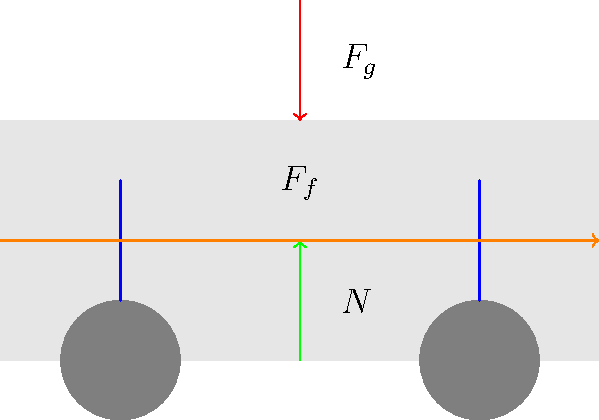During emergency braking, a truck's weight shifts forward, affecting the suspension system. If the truck's mass is 10,000 kg and it decelerates at 5 m/s², what is the magnitude of the friction force ($F_f$) acting on the truck? To solve this problem, we'll follow these steps:

1. Identify the given information:
   - Mass of the truck (m) = 10,000 kg
   - Deceleration (a) = 5 m/s²

2. Recall Newton's Second Law of Motion:
   $F = ma$

3. In this case, the friction force ($F_f$) is the force causing the deceleration:
   $F_f = ma$

4. Substitute the values into the equation:
   $F_f = 10,000 \text{ kg} \times 5 \text{ m/s²}$

5. Calculate the friction force:
   $F_f = 50,000 \text{ N}$

Therefore, the magnitude of the friction force acting on the truck during emergency braking is 50,000 N.
Answer: 50,000 N 